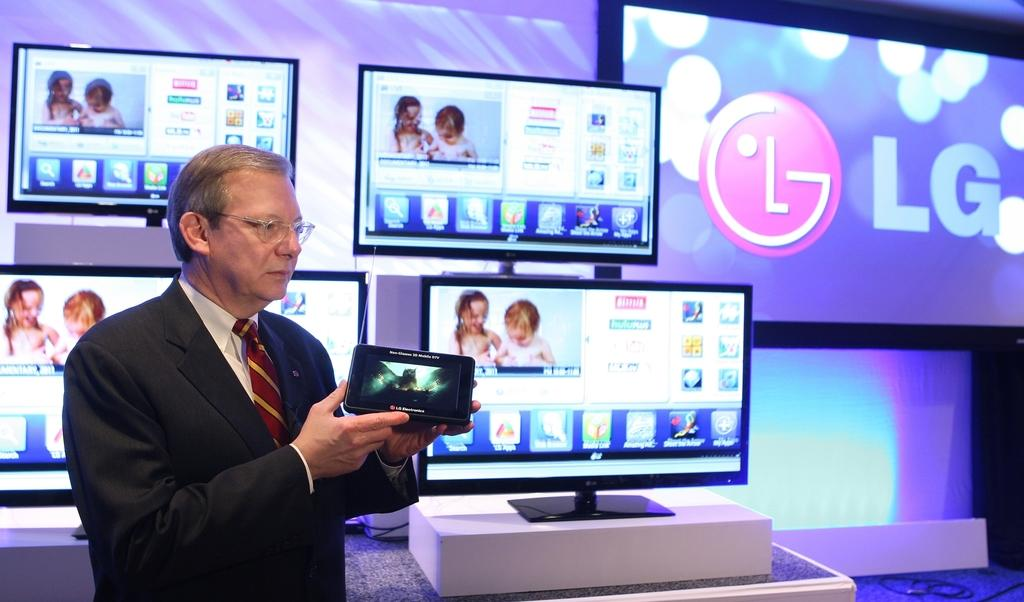<image>
Provide a brief description of the given image. Several LG branded monitors and televisions with a man posing in front of them. 